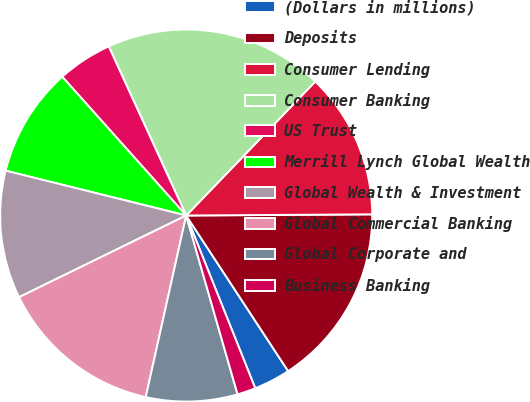<chart> <loc_0><loc_0><loc_500><loc_500><pie_chart><fcel>(Dollars in millions)<fcel>Deposits<fcel>Consumer Lending<fcel>Consumer Banking<fcel>US Trust<fcel>Merrill Lynch Global Wealth<fcel>Global Wealth & Investment<fcel>Global Commercial Banking<fcel>Global Corporate and<fcel>Business Banking<nl><fcel>3.18%<fcel>15.87%<fcel>12.7%<fcel>19.04%<fcel>4.77%<fcel>9.52%<fcel>11.11%<fcel>14.28%<fcel>7.94%<fcel>1.6%<nl></chart> 